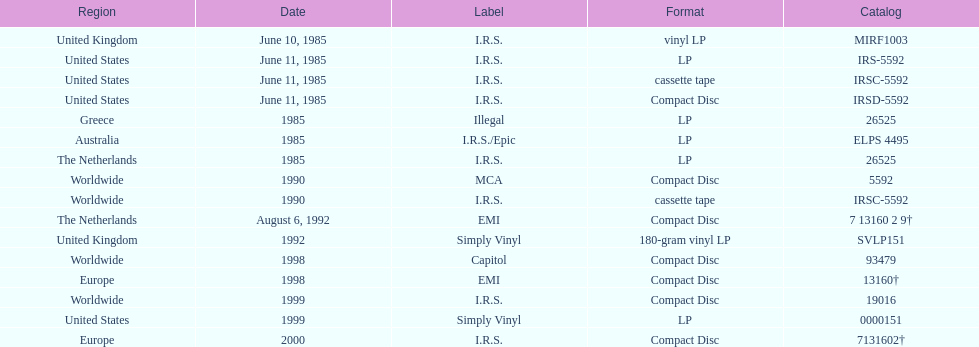What's the count of the album's releases? 13. 